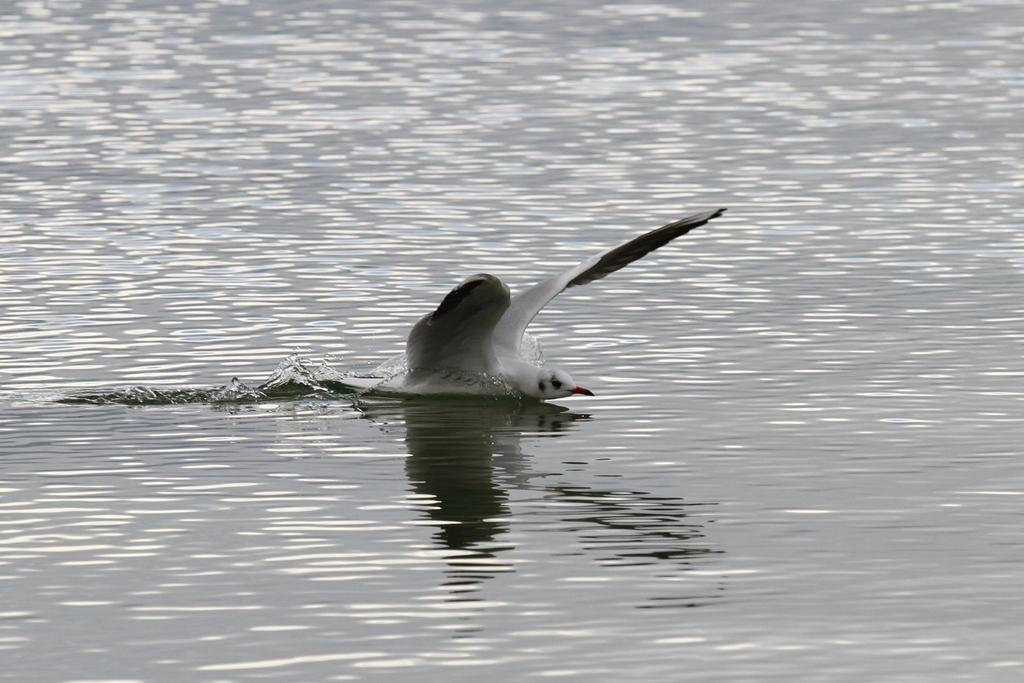What type of animal is in the image? There is a bird in the image. Where is the bird located in the image? The bird is in the water. What type of net can be seen holding the giraffe in the image? There is no giraffe or net present in the image; it features a bird in the water. What part of the bird is visible in the image? The entire bird is visible in the image, as it is not partially obscured or cut off. 